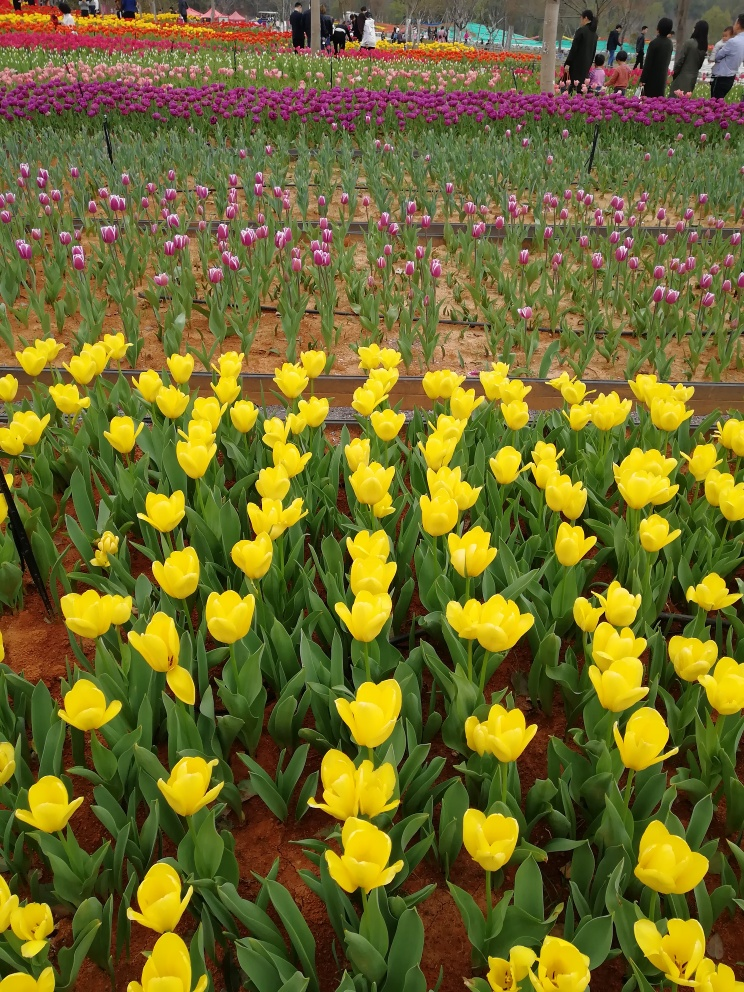What types of tulips are visible in this image, and what can you tell me about them? The image displays several types of tulips, primarily yellow and purple variations. These include the vibrant 'Golden Apeldoorn', known for their bright yellow blossoms and strong stems, and the 'Purple Flag', which is admired for its deep purple hue that contrasts beautifully against lighter colors. Tulips are perennials, blooming in spring, and they have been cultivated for their beauty and variety for centuries, often symbolizing perfect love. 